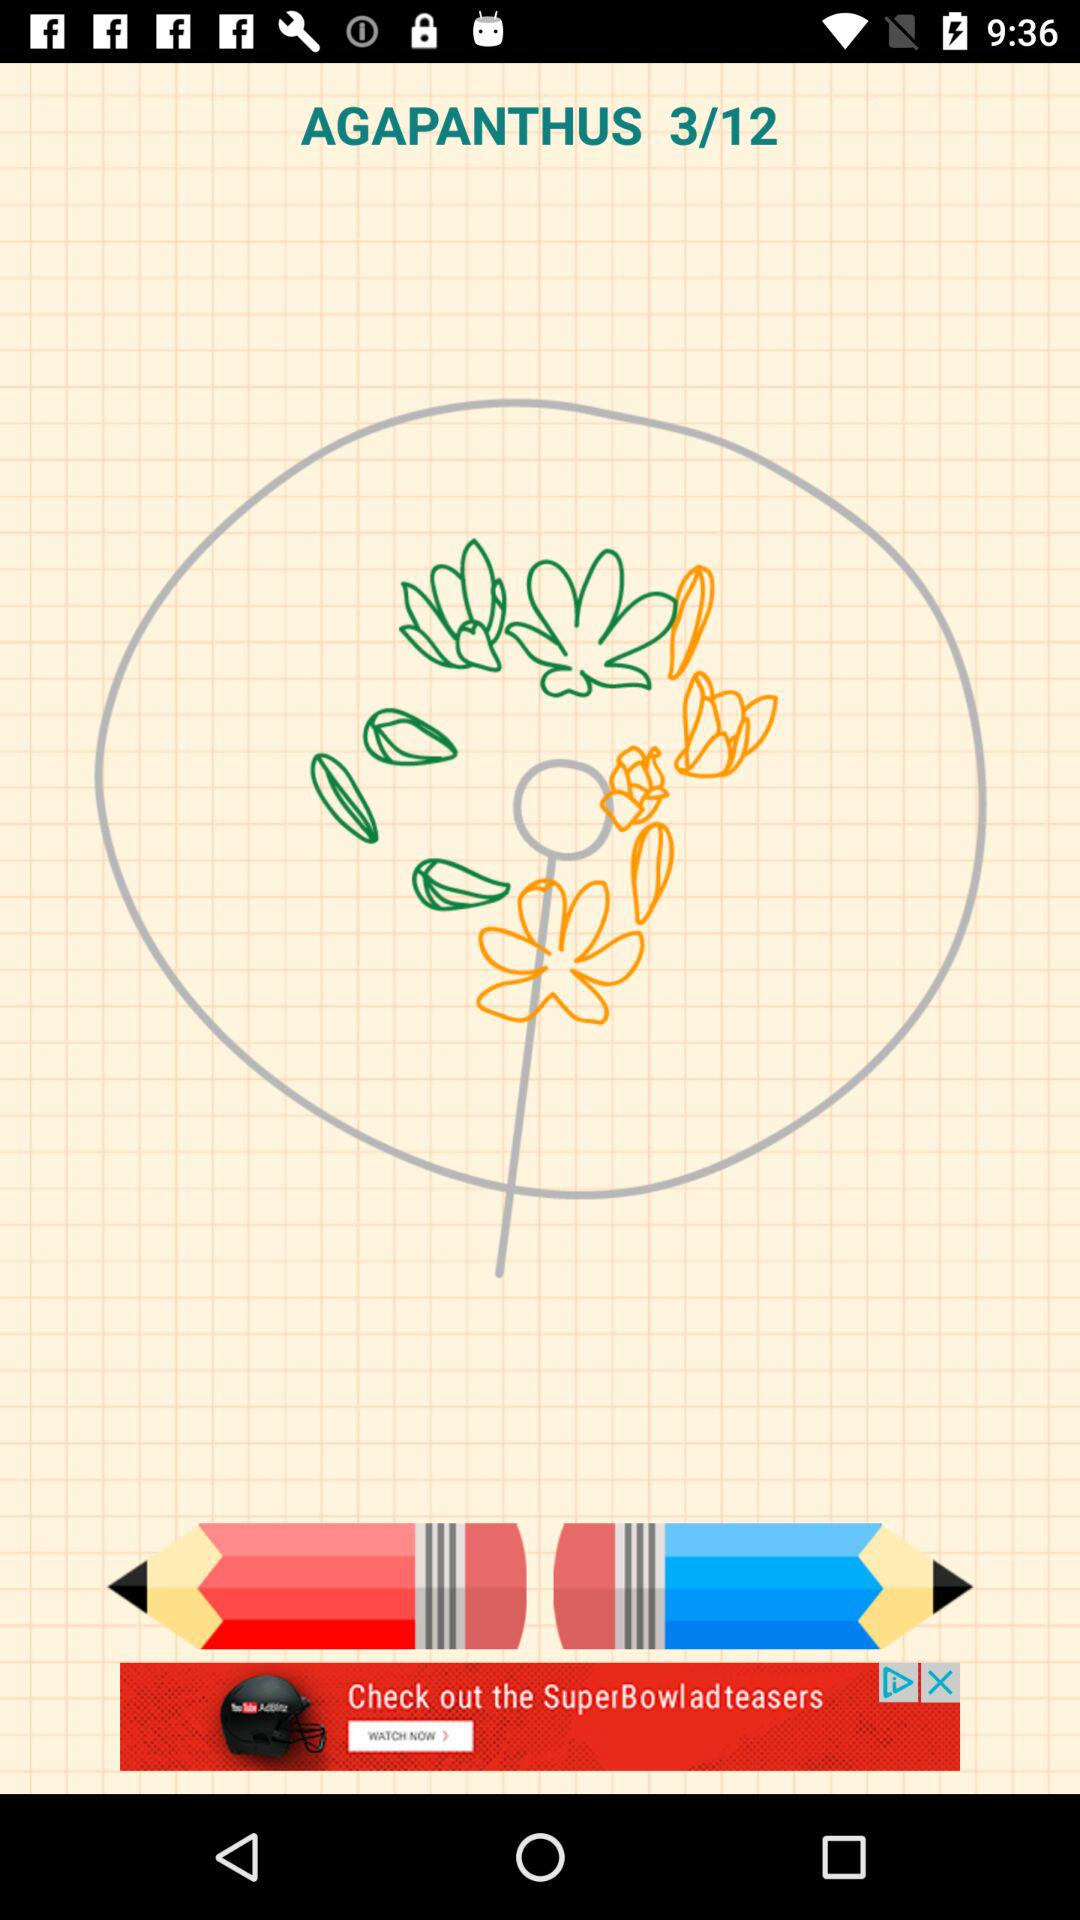What's the total number of steps? The total number of steps is 12. 